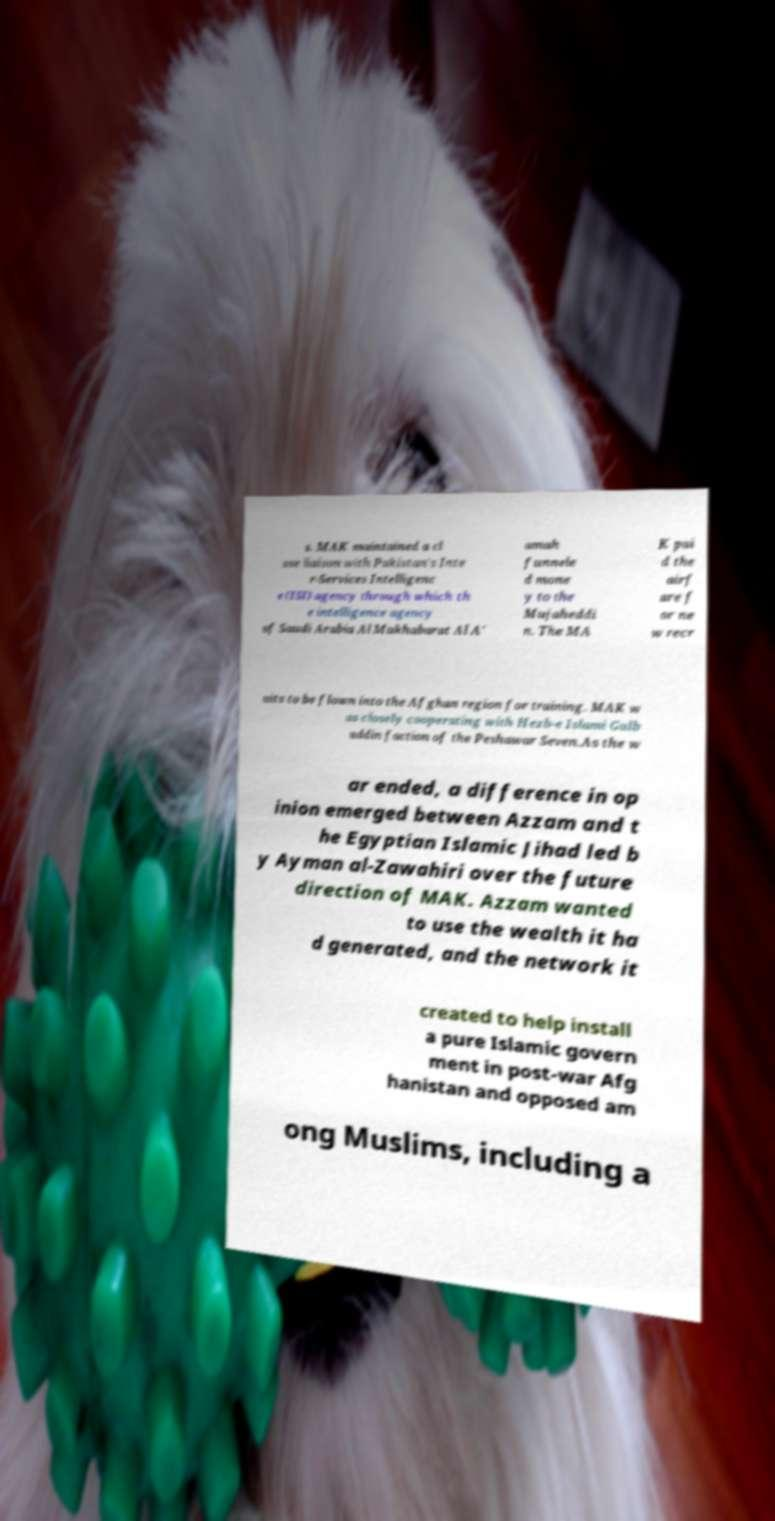Please identify and transcribe the text found in this image. s. MAK maintained a cl ose liaison with Pakistan's Inte r-Services Intelligenc e (ISI) agency through which th e intelligence agency of Saudi Arabia Al Mukhabarat Al A' amah funnele d mone y to the Mujaheddi n. The MA K pai d the airf are f or ne w recr uits to be flown into the Afghan region for training. MAK w as closely cooperating with Hezb-e Islami Gulb uddin faction of the Peshawar Seven.As the w ar ended, a difference in op inion emerged between Azzam and t he Egyptian Islamic Jihad led b y Ayman al-Zawahiri over the future direction of MAK. Azzam wanted to use the wealth it ha d generated, and the network it created to help install a pure Islamic govern ment in post-war Afg hanistan and opposed am ong Muslims, including a 